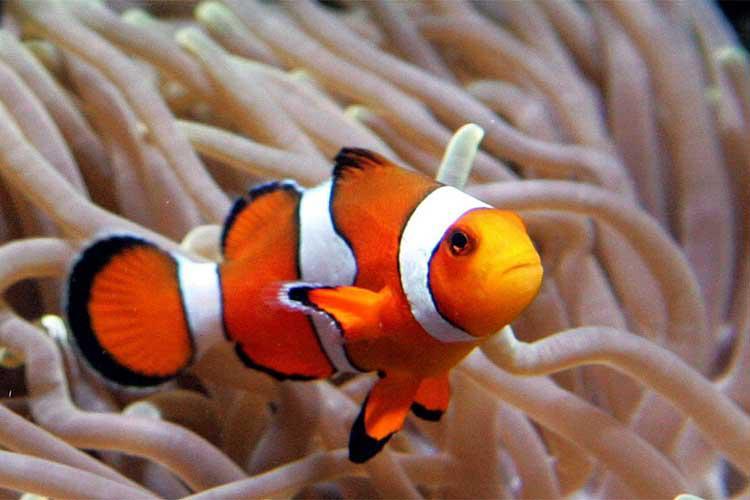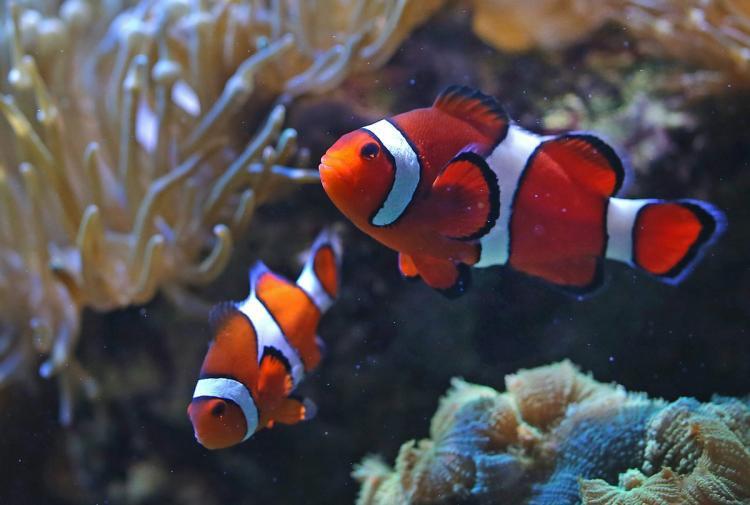The first image is the image on the left, the second image is the image on the right. Given the left and right images, does the statement "There are 4 clownfish." hold true? Answer yes or no. No. 